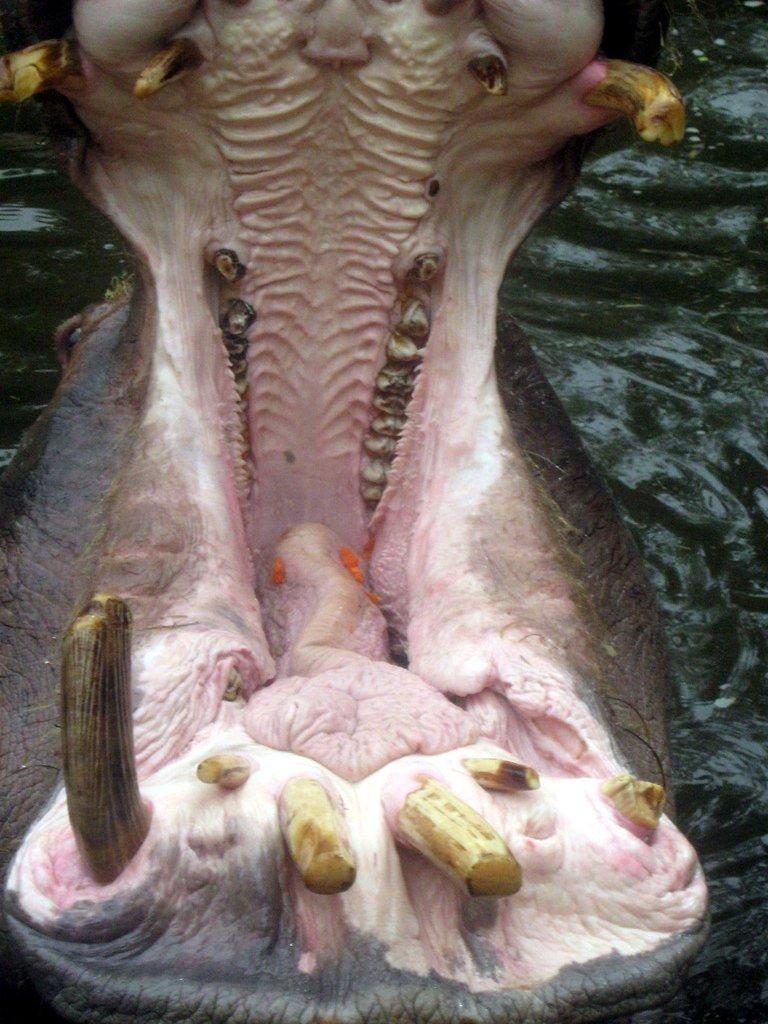What animal is present in the image? There is a hippopotamus in the image. Where is the hippopotamus located? The hippopotamus is in water. What type of holiday is the hippopotamus celebrating in the image? There is no indication of a holiday in the image; it simply shows a hippopotamus in water. 